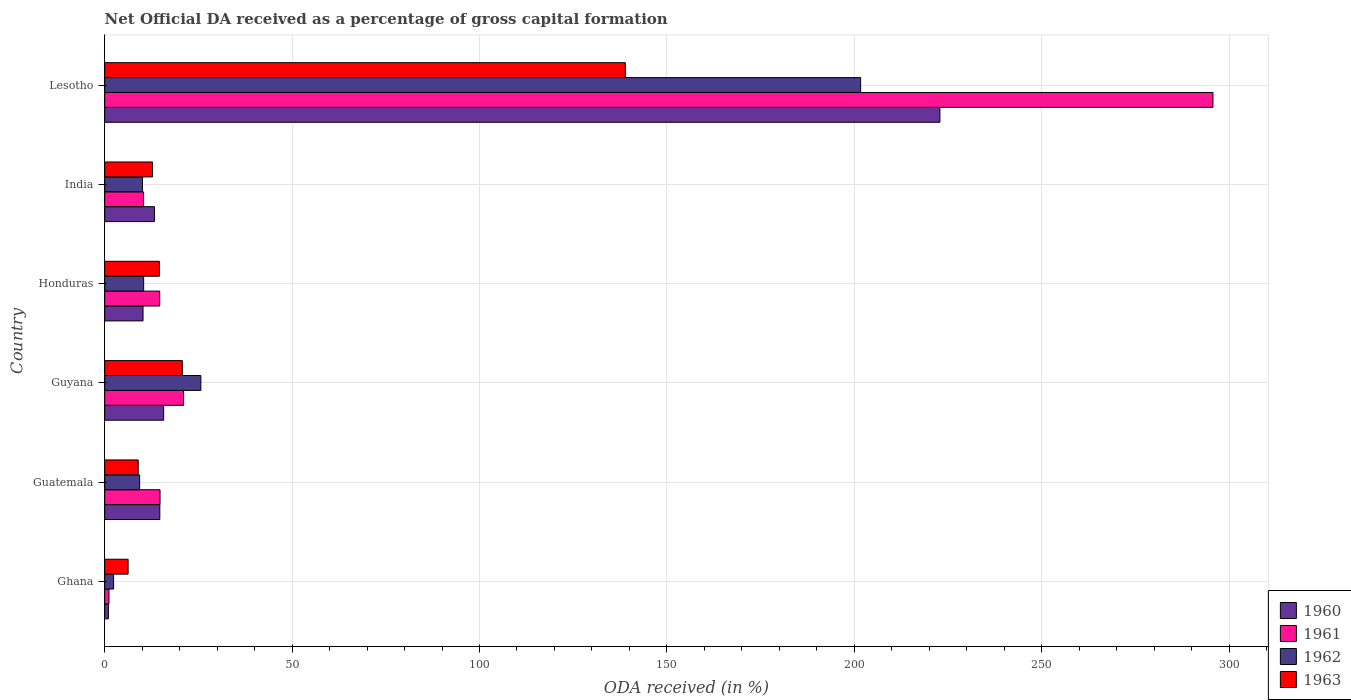How many bars are there on the 1st tick from the top?
Make the answer very short. 4. What is the label of the 5th group of bars from the top?
Ensure brevity in your answer.  Guatemala. In how many cases, is the number of bars for a given country not equal to the number of legend labels?
Offer a terse response. 0. What is the net ODA received in 1961 in Lesotho?
Make the answer very short. 295.71. Across all countries, what is the maximum net ODA received in 1962?
Give a very brief answer. 201.7. Across all countries, what is the minimum net ODA received in 1960?
Provide a short and direct response. 0.99. In which country was the net ODA received in 1960 maximum?
Ensure brevity in your answer.  Lesotho. In which country was the net ODA received in 1961 minimum?
Your answer should be very brief. Ghana. What is the total net ODA received in 1961 in the graph?
Give a very brief answer. 357.71. What is the difference between the net ODA received in 1963 in Guatemala and that in Guyana?
Your answer should be compact. -11.78. What is the difference between the net ODA received in 1960 in India and the net ODA received in 1963 in Guatemala?
Your answer should be compact. 4.34. What is the average net ODA received in 1962 per country?
Your answer should be very brief. 43.25. What is the difference between the net ODA received in 1963 and net ODA received in 1960 in Guyana?
Offer a very short reply. 4.98. In how many countries, is the net ODA received in 1963 greater than 120 %?
Your response must be concise. 1. What is the ratio of the net ODA received in 1962 in Ghana to that in Guatemala?
Provide a succinct answer. 0.25. Is the difference between the net ODA received in 1963 in Ghana and Lesotho greater than the difference between the net ODA received in 1960 in Ghana and Lesotho?
Offer a terse response. Yes. What is the difference between the highest and the second highest net ODA received in 1963?
Offer a terse response. 118.2. What is the difference between the highest and the lowest net ODA received in 1961?
Your answer should be compact. 294.58. Is it the case that in every country, the sum of the net ODA received in 1963 and net ODA received in 1961 is greater than the sum of net ODA received in 1960 and net ODA received in 1962?
Give a very brief answer. No. Is it the case that in every country, the sum of the net ODA received in 1963 and net ODA received in 1962 is greater than the net ODA received in 1961?
Give a very brief answer. Yes. How many countries are there in the graph?
Give a very brief answer. 6. Where does the legend appear in the graph?
Give a very brief answer. Bottom right. What is the title of the graph?
Your response must be concise. Net Official DA received as a percentage of gross capital formation. Does "2004" appear as one of the legend labels in the graph?
Your answer should be compact. No. What is the label or title of the X-axis?
Provide a short and direct response. ODA received (in %). What is the label or title of the Y-axis?
Provide a succinct answer. Country. What is the ODA received (in %) of 1960 in Ghana?
Your answer should be very brief. 0.99. What is the ODA received (in %) of 1961 in Ghana?
Provide a succinct answer. 1.13. What is the ODA received (in %) of 1962 in Ghana?
Offer a very short reply. 2.37. What is the ODA received (in %) of 1963 in Ghana?
Offer a terse response. 6.24. What is the ODA received (in %) in 1960 in Guatemala?
Provide a short and direct response. 14.71. What is the ODA received (in %) in 1961 in Guatemala?
Offer a terse response. 14.76. What is the ODA received (in %) in 1962 in Guatemala?
Keep it short and to the point. 9.31. What is the ODA received (in %) in 1963 in Guatemala?
Your answer should be very brief. 8.93. What is the ODA received (in %) of 1960 in Guyana?
Your answer should be very brief. 15.73. What is the ODA received (in %) of 1961 in Guyana?
Provide a succinct answer. 21.05. What is the ODA received (in %) in 1962 in Guyana?
Ensure brevity in your answer.  25.65. What is the ODA received (in %) in 1963 in Guyana?
Offer a terse response. 20.71. What is the ODA received (in %) in 1960 in Honduras?
Provide a short and direct response. 10.23. What is the ODA received (in %) of 1961 in Honduras?
Your answer should be very brief. 14.68. What is the ODA received (in %) in 1962 in Honduras?
Your answer should be compact. 10.39. What is the ODA received (in %) of 1963 in Honduras?
Your response must be concise. 14.59. What is the ODA received (in %) of 1960 in India?
Offer a very short reply. 13.27. What is the ODA received (in %) in 1961 in India?
Your answer should be compact. 10.37. What is the ODA received (in %) of 1962 in India?
Keep it short and to the point. 10.08. What is the ODA received (in %) in 1963 in India?
Your answer should be very brief. 12.76. What is the ODA received (in %) in 1960 in Lesotho?
Give a very brief answer. 222.86. What is the ODA received (in %) of 1961 in Lesotho?
Make the answer very short. 295.71. What is the ODA received (in %) of 1962 in Lesotho?
Make the answer very short. 201.7. What is the ODA received (in %) in 1963 in Lesotho?
Make the answer very short. 138.92. Across all countries, what is the maximum ODA received (in %) in 1960?
Give a very brief answer. 222.86. Across all countries, what is the maximum ODA received (in %) in 1961?
Keep it short and to the point. 295.71. Across all countries, what is the maximum ODA received (in %) in 1962?
Provide a short and direct response. 201.7. Across all countries, what is the maximum ODA received (in %) in 1963?
Your answer should be compact. 138.92. Across all countries, what is the minimum ODA received (in %) of 1960?
Offer a very short reply. 0.99. Across all countries, what is the minimum ODA received (in %) in 1961?
Provide a succinct answer. 1.13. Across all countries, what is the minimum ODA received (in %) in 1962?
Ensure brevity in your answer.  2.37. Across all countries, what is the minimum ODA received (in %) in 1963?
Offer a terse response. 6.24. What is the total ODA received (in %) in 1960 in the graph?
Offer a very short reply. 277.78. What is the total ODA received (in %) in 1961 in the graph?
Offer a terse response. 357.71. What is the total ODA received (in %) in 1962 in the graph?
Give a very brief answer. 259.51. What is the total ODA received (in %) of 1963 in the graph?
Provide a succinct answer. 202.15. What is the difference between the ODA received (in %) in 1960 in Ghana and that in Guatemala?
Give a very brief answer. -13.72. What is the difference between the ODA received (in %) in 1961 in Ghana and that in Guatemala?
Your response must be concise. -13.63. What is the difference between the ODA received (in %) in 1962 in Ghana and that in Guatemala?
Provide a short and direct response. -6.94. What is the difference between the ODA received (in %) of 1963 in Ghana and that in Guatemala?
Keep it short and to the point. -2.69. What is the difference between the ODA received (in %) of 1960 in Ghana and that in Guyana?
Ensure brevity in your answer.  -14.74. What is the difference between the ODA received (in %) in 1961 in Ghana and that in Guyana?
Offer a terse response. -19.91. What is the difference between the ODA received (in %) of 1962 in Ghana and that in Guyana?
Ensure brevity in your answer.  -23.28. What is the difference between the ODA received (in %) of 1963 in Ghana and that in Guyana?
Give a very brief answer. -14.47. What is the difference between the ODA received (in %) of 1960 in Ghana and that in Honduras?
Your answer should be very brief. -9.23. What is the difference between the ODA received (in %) of 1961 in Ghana and that in Honduras?
Provide a short and direct response. -13.54. What is the difference between the ODA received (in %) of 1962 in Ghana and that in Honduras?
Provide a succinct answer. -8.02. What is the difference between the ODA received (in %) of 1963 in Ghana and that in Honduras?
Offer a very short reply. -8.35. What is the difference between the ODA received (in %) of 1960 in Ghana and that in India?
Offer a terse response. -12.28. What is the difference between the ODA received (in %) of 1961 in Ghana and that in India?
Offer a terse response. -9.24. What is the difference between the ODA received (in %) in 1962 in Ghana and that in India?
Your answer should be very brief. -7.71. What is the difference between the ODA received (in %) of 1963 in Ghana and that in India?
Offer a very short reply. -6.51. What is the difference between the ODA received (in %) of 1960 in Ghana and that in Lesotho?
Offer a terse response. -221.87. What is the difference between the ODA received (in %) in 1961 in Ghana and that in Lesotho?
Provide a short and direct response. -294.58. What is the difference between the ODA received (in %) of 1962 in Ghana and that in Lesotho?
Give a very brief answer. -199.33. What is the difference between the ODA received (in %) of 1963 in Ghana and that in Lesotho?
Your answer should be compact. -132.67. What is the difference between the ODA received (in %) in 1960 in Guatemala and that in Guyana?
Provide a short and direct response. -1.02. What is the difference between the ODA received (in %) in 1961 in Guatemala and that in Guyana?
Give a very brief answer. -6.29. What is the difference between the ODA received (in %) of 1962 in Guatemala and that in Guyana?
Offer a very short reply. -16.34. What is the difference between the ODA received (in %) of 1963 in Guatemala and that in Guyana?
Ensure brevity in your answer.  -11.78. What is the difference between the ODA received (in %) in 1960 in Guatemala and that in Honduras?
Give a very brief answer. 4.48. What is the difference between the ODA received (in %) of 1961 in Guatemala and that in Honduras?
Make the answer very short. 0.08. What is the difference between the ODA received (in %) of 1962 in Guatemala and that in Honduras?
Give a very brief answer. -1.08. What is the difference between the ODA received (in %) of 1963 in Guatemala and that in Honduras?
Provide a short and direct response. -5.66. What is the difference between the ODA received (in %) of 1960 in Guatemala and that in India?
Offer a very short reply. 1.44. What is the difference between the ODA received (in %) in 1961 in Guatemala and that in India?
Provide a succinct answer. 4.39. What is the difference between the ODA received (in %) of 1962 in Guatemala and that in India?
Your response must be concise. -0.77. What is the difference between the ODA received (in %) of 1963 in Guatemala and that in India?
Offer a very short reply. -3.82. What is the difference between the ODA received (in %) of 1960 in Guatemala and that in Lesotho?
Ensure brevity in your answer.  -208.15. What is the difference between the ODA received (in %) in 1961 in Guatemala and that in Lesotho?
Provide a succinct answer. -280.95. What is the difference between the ODA received (in %) in 1962 in Guatemala and that in Lesotho?
Ensure brevity in your answer.  -192.39. What is the difference between the ODA received (in %) in 1963 in Guatemala and that in Lesotho?
Your answer should be very brief. -129.98. What is the difference between the ODA received (in %) of 1960 in Guyana and that in Honduras?
Give a very brief answer. 5.5. What is the difference between the ODA received (in %) in 1961 in Guyana and that in Honduras?
Give a very brief answer. 6.37. What is the difference between the ODA received (in %) in 1962 in Guyana and that in Honduras?
Make the answer very short. 15.26. What is the difference between the ODA received (in %) of 1963 in Guyana and that in Honduras?
Your answer should be very brief. 6.12. What is the difference between the ODA received (in %) of 1960 in Guyana and that in India?
Keep it short and to the point. 2.46. What is the difference between the ODA received (in %) in 1961 in Guyana and that in India?
Provide a short and direct response. 10.67. What is the difference between the ODA received (in %) of 1962 in Guyana and that in India?
Ensure brevity in your answer.  15.57. What is the difference between the ODA received (in %) in 1963 in Guyana and that in India?
Keep it short and to the point. 7.96. What is the difference between the ODA received (in %) in 1960 in Guyana and that in Lesotho?
Offer a very short reply. -207.13. What is the difference between the ODA received (in %) in 1961 in Guyana and that in Lesotho?
Ensure brevity in your answer.  -274.67. What is the difference between the ODA received (in %) in 1962 in Guyana and that in Lesotho?
Make the answer very short. -176.05. What is the difference between the ODA received (in %) in 1963 in Guyana and that in Lesotho?
Give a very brief answer. -118.2. What is the difference between the ODA received (in %) of 1960 in Honduras and that in India?
Provide a short and direct response. -3.05. What is the difference between the ODA received (in %) in 1961 in Honduras and that in India?
Give a very brief answer. 4.3. What is the difference between the ODA received (in %) in 1962 in Honduras and that in India?
Your response must be concise. 0.31. What is the difference between the ODA received (in %) in 1963 in Honduras and that in India?
Keep it short and to the point. 1.84. What is the difference between the ODA received (in %) of 1960 in Honduras and that in Lesotho?
Provide a short and direct response. -212.63. What is the difference between the ODA received (in %) in 1961 in Honduras and that in Lesotho?
Provide a succinct answer. -281.04. What is the difference between the ODA received (in %) in 1962 in Honduras and that in Lesotho?
Give a very brief answer. -191.31. What is the difference between the ODA received (in %) of 1963 in Honduras and that in Lesotho?
Offer a very short reply. -124.33. What is the difference between the ODA received (in %) in 1960 in India and that in Lesotho?
Your answer should be very brief. -209.59. What is the difference between the ODA received (in %) in 1961 in India and that in Lesotho?
Your response must be concise. -285.34. What is the difference between the ODA received (in %) of 1962 in India and that in Lesotho?
Ensure brevity in your answer.  -191.62. What is the difference between the ODA received (in %) of 1963 in India and that in Lesotho?
Provide a succinct answer. -126.16. What is the difference between the ODA received (in %) in 1960 in Ghana and the ODA received (in %) in 1961 in Guatemala?
Your answer should be compact. -13.77. What is the difference between the ODA received (in %) of 1960 in Ghana and the ODA received (in %) of 1962 in Guatemala?
Provide a succinct answer. -8.32. What is the difference between the ODA received (in %) in 1960 in Ghana and the ODA received (in %) in 1963 in Guatemala?
Your answer should be compact. -7.94. What is the difference between the ODA received (in %) of 1961 in Ghana and the ODA received (in %) of 1962 in Guatemala?
Ensure brevity in your answer.  -8.18. What is the difference between the ODA received (in %) in 1961 in Ghana and the ODA received (in %) in 1963 in Guatemala?
Offer a very short reply. -7.8. What is the difference between the ODA received (in %) in 1962 in Ghana and the ODA received (in %) in 1963 in Guatemala?
Your response must be concise. -6.56. What is the difference between the ODA received (in %) of 1960 in Ghana and the ODA received (in %) of 1961 in Guyana?
Your response must be concise. -20.06. What is the difference between the ODA received (in %) in 1960 in Ghana and the ODA received (in %) in 1962 in Guyana?
Give a very brief answer. -24.66. What is the difference between the ODA received (in %) in 1960 in Ghana and the ODA received (in %) in 1963 in Guyana?
Keep it short and to the point. -19.72. What is the difference between the ODA received (in %) in 1961 in Ghana and the ODA received (in %) in 1962 in Guyana?
Keep it short and to the point. -24.52. What is the difference between the ODA received (in %) of 1961 in Ghana and the ODA received (in %) of 1963 in Guyana?
Keep it short and to the point. -19.58. What is the difference between the ODA received (in %) of 1962 in Ghana and the ODA received (in %) of 1963 in Guyana?
Offer a very short reply. -18.34. What is the difference between the ODA received (in %) in 1960 in Ghana and the ODA received (in %) in 1961 in Honduras?
Give a very brief answer. -13.69. What is the difference between the ODA received (in %) of 1960 in Ghana and the ODA received (in %) of 1962 in Honduras?
Your answer should be compact. -9.4. What is the difference between the ODA received (in %) in 1960 in Ghana and the ODA received (in %) in 1963 in Honduras?
Keep it short and to the point. -13.6. What is the difference between the ODA received (in %) in 1961 in Ghana and the ODA received (in %) in 1962 in Honduras?
Provide a succinct answer. -9.26. What is the difference between the ODA received (in %) in 1961 in Ghana and the ODA received (in %) in 1963 in Honduras?
Offer a terse response. -13.46. What is the difference between the ODA received (in %) of 1962 in Ghana and the ODA received (in %) of 1963 in Honduras?
Make the answer very short. -12.22. What is the difference between the ODA received (in %) in 1960 in Ghana and the ODA received (in %) in 1961 in India?
Offer a very short reply. -9.38. What is the difference between the ODA received (in %) of 1960 in Ghana and the ODA received (in %) of 1962 in India?
Provide a succinct answer. -9.09. What is the difference between the ODA received (in %) of 1960 in Ghana and the ODA received (in %) of 1963 in India?
Provide a short and direct response. -11.77. What is the difference between the ODA received (in %) in 1961 in Ghana and the ODA received (in %) in 1962 in India?
Make the answer very short. -8.95. What is the difference between the ODA received (in %) of 1961 in Ghana and the ODA received (in %) of 1963 in India?
Your answer should be compact. -11.62. What is the difference between the ODA received (in %) of 1962 in Ghana and the ODA received (in %) of 1963 in India?
Ensure brevity in your answer.  -10.39. What is the difference between the ODA received (in %) of 1960 in Ghana and the ODA received (in %) of 1961 in Lesotho?
Provide a short and direct response. -294.72. What is the difference between the ODA received (in %) in 1960 in Ghana and the ODA received (in %) in 1962 in Lesotho?
Provide a short and direct response. -200.71. What is the difference between the ODA received (in %) in 1960 in Ghana and the ODA received (in %) in 1963 in Lesotho?
Ensure brevity in your answer.  -137.93. What is the difference between the ODA received (in %) in 1961 in Ghana and the ODA received (in %) in 1962 in Lesotho?
Give a very brief answer. -200.57. What is the difference between the ODA received (in %) of 1961 in Ghana and the ODA received (in %) of 1963 in Lesotho?
Provide a short and direct response. -137.78. What is the difference between the ODA received (in %) of 1962 in Ghana and the ODA received (in %) of 1963 in Lesotho?
Keep it short and to the point. -136.55. What is the difference between the ODA received (in %) of 1960 in Guatemala and the ODA received (in %) of 1961 in Guyana?
Provide a succinct answer. -6.34. What is the difference between the ODA received (in %) in 1960 in Guatemala and the ODA received (in %) in 1962 in Guyana?
Provide a short and direct response. -10.95. What is the difference between the ODA received (in %) in 1960 in Guatemala and the ODA received (in %) in 1963 in Guyana?
Make the answer very short. -6.01. What is the difference between the ODA received (in %) of 1961 in Guatemala and the ODA received (in %) of 1962 in Guyana?
Provide a short and direct response. -10.89. What is the difference between the ODA received (in %) in 1961 in Guatemala and the ODA received (in %) in 1963 in Guyana?
Ensure brevity in your answer.  -5.95. What is the difference between the ODA received (in %) of 1962 in Guatemala and the ODA received (in %) of 1963 in Guyana?
Offer a terse response. -11.4. What is the difference between the ODA received (in %) in 1960 in Guatemala and the ODA received (in %) in 1961 in Honduras?
Your answer should be compact. 0.03. What is the difference between the ODA received (in %) in 1960 in Guatemala and the ODA received (in %) in 1962 in Honduras?
Ensure brevity in your answer.  4.32. What is the difference between the ODA received (in %) in 1960 in Guatemala and the ODA received (in %) in 1963 in Honduras?
Your answer should be compact. 0.12. What is the difference between the ODA received (in %) of 1961 in Guatemala and the ODA received (in %) of 1962 in Honduras?
Provide a succinct answer. 4.37. What is the difference between the ODA received (in %) of 1961 in Guatemala and the ODA received (in %) of 1963 in Honduras?
Make the answer very short. 0.17. What is the difference between the ODA received (in %) of 1962 in Guatemala and the ODA received (in %) of 1963 in Honduras?
Offer a very short reply. -5.28. What is the difference between the ODA received (in %) of 1960 in Guatemala and the ODA received (in %) of 1961 in India?
Ensure brevity in your answer.  4.33. What is the difference between the ODA received (in %) in 1960 in Guatemala and the ODA received (in %) in 1962 in India?
Offer a terse response. 4.63. What is the difference between the ODA received (in %) in 1960 in Guatemala and the ODA received (in %) in 1963 in India?
Offer a terse response. 1.95. What is the difference between the ODA received (in %) of 1961 in Guatemala and the ODA received (in %) of 1962 in India?
Your response must be concise. 4.68. What is the difference between the ODA received (in %) in 1961 in Guatemala and the ODA received (in %) in 1963 in India?
Your answer should be very brief. 2. What is the difference between the ODA received (in %) in 1962 in Guatemala and the ODA received (in %) in 1963 in India?
Make the answer very short. -3.44. What is the difference between the ODA received (in %) in 1960 in Guatemala and the ODA received (in %) in 1961 in Lesotho?
Ensure brevity in your answer.  -281.01. What is the difference between the ODA received (in %) in 1960 in Guatemala and the ODA received (in %) in 1962 in Lesotho?
Give a very brief answer. -186.99. What is the difference between the ODA received (in %) in 1960 in Guatemala and the ODA received (in %) in 1963 in Lesotho?
Make the answer very short. -124.21. What is the difference between the ODA received (in %) in 1961 in Guatemala and the ODA received (in %) in 1962 in Lesotho?
Offer a very short reply. -186.94. What is the difference between the ODA received (in %) in 1961 in Guatemala and the ODA received (in %) in 1963 in Lesotho?
Offer a terse response. -124.16. What is the difference between the ODA received (in %) of 1962 in Guatemala and the ODA received (in %) of 1963 in Lesotho?
Your answer should be very brief. -129.6. What is the difference between the ODA received (in %) of 1960 in Guyana and the ODA received (in %) of 1961 in Honduras?
Provide a succinct answer. 1.05. What is the difference between the ODA received (in %) in 1960 in Guyana and the ODA received (in %) in 1962 in Honduras?
Give a very brief answer. 5.34. What is the difference between the ODA received (in %) in 1960 in Guyana and the ODA received (in %) in 1963 in Honduras?
Your answer should be very brief. 1.14. What is the difference between the ODA received (in %) in 1961 in Guyana and the ODA received (in %) in 1962 in Honduras?
Your response must be concise. 10.66. What is the difference between the ODA received (in %) of 1961 in Guyana and the ODA received (in %) of 1963 in Honduras?
Provide a succinct answer. 6.46. What is the difference between the ODA received (in %) of 1962 in Guyana and the ODA received (in %) of 1963 in Honduras?
Keep it short and to the point. 11.06. What is the difference between the ODA received (in %) in 1960 in Guyana and the ODA received (in %) in 1961 in India?
Ensure brevity in your answer.  5.36. What is the difference between the ODA received (in %) of 1960 in Guyana and the ODA received (in %) of 1962 in India?
Provide a succinct answer. 5.65. What is the difference between the ODA received (in %) of 1960 in Guyana and the ODA received (in %) of 1963 in India?
Your answer should be compact. 2.97. What is the difference between the ODA received (in %) in 1961 in Guyana and the ODA received (in %) in 1962 in India?
Offer a terse response. 10.97. What is the difference between the ODA received (in %) of 1961 in Guyana and the ODA received (in %) of 1963 in India?
Make the answer very short. 8.29. What is the difference between the ODA received (in %) in 1962 in Guyana and the ODA received (in %) in 1963 in India?
Your answer should be very brief. 12.9. What is the difference between the ODA received (in %) of 1960 in Guyana and the ODA received (in %) of 1961 in Lesotho?
Give a very brief answer. -279.98. What is the difference between the ODA received (in %) in 1960 in Guyana and the ODA received (in %) in 1962 in Lesotho?
Your answer should be very brief. -185.97. What is the difference between the ODA received (in %) of 1960 in Guyana and the ODA received (in %) of 1963 in Lesotho?
Offer a terse response. -123.19. What is the difference between the ODA received (in %) of 1961 in Guyana and the ODA received (in %) of 1962 in Lesotho?
Offer a terse response. -180.65. What is the difference between the ODA received (in %) in 1961 in Guyana and the ODA received (in %) in 1963 in Lesotho?
Give a very brief answer. -117.87. What is the difference between the ODA received (in %) in 1962 in Guyana and the ODA received (in %) in 1963 in Lesotho?
Provide a short and direct response. -113.26. What is the difference between the ODA received (in %) of 1960 in Honduras and the ODA received (in %) of 1961 in India?
Ensure brevity in your answer.  -0.15. What is the difference between the ODA received (in %) in 1960 in Honduras and the ODA received (in %) in 1962 in India?
Offer a terse response. 0.14. What is the difference between the ODA received (in %) in 1960 in Honduras and the ODA received (in %) in 1963 in India?
Give a very brief answer. -2.53. What is the difference between the ODA received (in %) in 1961 in Honduras and the ODA received (in %) in 1962 in India?
Offer a very short reply. 4.6. What is the difference between the ODA received (in %) in 1961 in Honduras and the ODA received (in %) in 1963 in India?
Keep it short and to the point. 1.92. What is the difference between the ODA received (in %) in 1962 in Honduras and the ODA received (in %) in 1963 in India?
Offer a terse response. -2.37. What is the difference between the ODA received (in %) of 1960 in Honduras and the ODA received (in %) of 1961 in Lesotho?
Provide a short and direct response. -285.49. What is the difference between the ODA received (in %) in 1960 in Honduras and the ODA received (in %) in 1962 in Lesotho?
Your answer should be compact. -191.48. What is the difference between the ODA received (in %) in 1960 in Honduras and the ODA received (in %) in 1963 in Lesotho?
Make the answer very short. -128.69. What is the difference between the ODA received (in %) of 1961 in Honduras and the ODA received (in %) of 1962 in Lesotho?
Provide a short and direct response. -187.02. What is the difference between the ODA received (in %) of 1961 in Honduras and the ODA received (in %) of 1963 in Lesotho?
Keep it short and to the point. -124.24. What is the difference between the ODA received (in %) in 1962 in Honduras and the ODA received (in %) in 1963 in Lesotho?
Give a very brief answer. -128.53. What is the difference between the ODA received (in %) in 1960 in India and the ODA received (in %) in 1961 in Lesotho?
Your response must be concise. -282.44. What is the difference between the ODA received (in %) of 1960 in India and the ODA received (in %) of 1962 in Lesotho?
Provide a succinct answer. -188.43. What is the difference between the ODA received (in %) of 1960 in India and the ODA received (in %) of 1963 in Lesotho?
Provide a short and direct response. -125.65. What is the difference between the ODA received (in %) in 1961 in India and the ODA received (in %) in 1962 in Lesotho?
Ensure brevity in your answer.  -191.33. What is the difference between the ODA received (in %) of 1961 in India and the ODA received (in %) of 1963 in Lesotho?
Your answer should be compact. -128.54. What is the difference between the ODA received (in %) of 1962 in India and the ODA received (in %) of 1963 in Lesotho?
Make the answer very short. -128.84. What is the average ODA received (in %) of 1960 per country?
Give a very brief answer. 46.3. What is the average ODA received (in %) in 1961 per country?
Keep it short and to the point. 59.62. What is the average ODA received (in %) in 1962 per country?
Your answer should be compact. 43.25. What is the average ODA received (in %) of 1963 per country?
Offer a very short reply. 33.69. What is the difference between the ODA received (in %) of 1960 and ODA received (in %) of 1961 in Ghana?
Provide a succinct answer. -0.14. What is the difference between the ODA received (in %) in 1960 and ODA received (in %) in 1962 in Ghana?
Offer a terse response. -1.38. What is the difference between the ODA received (in %) of 1960 and ODA received (in %) of 1963 in Ghana?
Give a very brief answer. -5.25. What is the difference between the ODA received (in %) of 1961 and ODA received (in %) of 1962 in Ghana?
Keep it short and to the point. -1.24. What is the difference between the ODA received (in %) of 1961 and ODA received (in %) of 1963 in Ghana?
Provide a succinct answer. -5.11. What is the difference between the ODA received (in %) of 1962 and ODA received (in %) of 1963 in Ghana?
Give a very brief answer. -3.87. What is the difference between the ODA received (in %) of 1960 and ODA received (in %) of 1961 in Guatemala?
Keep it short and to the point. -0.05. What is the difference between the ODA received (in %) of 1960 and ODA received (in %) of 1962 in Guatemala?
Offer a very short reply. 5.39. What is the difference between the ODA received (in %) in 1960 and ODA received (in %) in 1963 in Guatemala?
Give a very brief answer. 5.77. What is the difference between the ODA received (in %) in 1961 and ODA received (in %) in 1962 in Guatemala?
Make the answer very short. 5.45. What is the difference between the ODA received (in %) in 1961 and ODA received (in %) in 1963 in Guatemala?
Your answer should be very brief. 5.83. What is the difference between the ODA received (in %) of 1962 and ODA received (in %) of 1963 in Guatemala?
Your answer should be very brief. 0.38. What is the difference between the ODA received (in %) in 1960 and ODA received (in %) in 1961 in Guyana?
Provide a short and direct response. -5.32. What is the difference between the ODA received (in %) of 1960 and ODA received (in %) of 1962 in Guyana?
Provide a short and direct response. -9.92. What is the difference between the ODA received (in %) of 1960 and ODA received (in %) of 1963 in Guyana?
Ensure brevity in your answer.  -4.98. What is the difference between the ODA received (in %) in 1961 and ODA received (in %) in 1962 in Guyana?
Your response must be concise. -4.61. What is the difference between the ODA received (in %) in 1961 and ODA received (in %) in 1963 in Guyana?
Provide a short and direct response. 0.33. What is the difference between the ODA received (in %) of 1962 and ODA received (in %) of 1963 in Guyana?
Your response must be concise. 4.94. What is the difference between the ODA received (in %) of 1960 and ODA received (in %) of 1961 in Honduras?
Ensure brevity in your answer.  -4.45. What is the difference between the ODA received (in %) in 1960 and ODA received (in %) in 1962 in Honduras?
Offer a terse response. -0.16. What is the difference between the ODA received (in %) in 1960 and ODA received (in %) in 1963 in Honduras?
Your answer should be compact. -4.37. What is the difference between the ODA received (in %) of 1961 and ODA received (in %) of 1962 in Honduras?
Your response must be concise. 4.29. What is the difference between the ODA received (in %) of 1961 and ODA received (in %) of 1963 in Honduras?
Give a very brief answer. 0.09. What is the difference between the ODA received (in %) of 1962 and ODA received (in %) of 1963 in Honduras?
Your answer should be very brief. -4.2. What is the difference between the ODA received (in %) of 1960 and ODA received (in %) of 1961 in India?
Offer a terse response. 2.9. What is the difference between the ODA received (in %) in 1960 and ODA received (in %) in 1962 in India?
Give a very brief answer. 3.19. What is the difference between the ODA received (in %) of 1960 and ODA received (in %) of 1963 in India?
Give a very brief answer. 0.52. What is the difference between the ODA received (in %) of 1961 and ODA received (in %) of 1962 in India?
Provide a short and direct response. 0.29. What is the difference between the ODA received (in %) of 1961 and ODA received (in %) of 1963 in India?
Your answer should be compact. -2.38. What is the difference between the ODA received (in %) of 1962 and ODA received (in %) of 1963 in India?
Offer a very short reply. -2.68. What is the difference between the ODA received (in %) in 1960 and ODA received (in %) in 1961 in Lesotho?
Offer a terse response. -72.86. What is the difference between the ODA received (in %) of 1960 and ODA received (in %) of 1962 in Lesotho?
Provide a short and direct response. 21.16. What is the difference between the ODA received (in %) in 1960 and ODA received (in %) in 1963 in Lesotho?
Ensure brevity in your answer.  83.94. What is the difference between the ODA received (in %) of 1961 and ODA received (in %) of 1962 in Lesotho?
Make the answer very short. 94.01. What is the difference between the ODA received (in %) of 1961 and ODA received (in %) of 1963 in Lesotho?
Offer a terse response. 156.8. What is the difference between the ODA received (in %) in 1962 and ODA received (in %) in 1963 in Lesotho?
Provide a short and direct response. 62.78. What is the ratio of the ODA received (in %) of 1960 in Ghana to that in Guatemala?
Make the answer very short. 0.07. What is the ratio of the ODA received (in %) of 1961 in Ghana to that in Guatemala?
Keep it short and to the point. 0.08. What is the ratio of the ODA received (in %) of 1962 in Ghana to that in Guatemala?
Ensure brevity in your answer.  0.25. What is the ratio of the ODA received (in %) of 1963 in Ghana to that in Guatemala?
Make the answer very short. 0.7. What is the ratio of the ODA received (in %) in 1960 in Ghana to that in Guyana?
Keep it short and to the point. 0.06. What is the ratio of the ODA received (in %) of 1961 in Ghana to that in Guyana?
Your response must be concise. 0.05. What is the ratio of the ODA received (in %) of 1962 in Ghana to that in Guyana?
Your response must be concise. 0.09. What is the ratio of the ODA received (in %) of 1963 in Ghana to that in Guyana?
Keep it short and to the point. 0.3. What is the ratio of the ODA received (in %) of 1960 in Ghana to that in Honduras?
Ensure brevity in your answer.  0.1. What is the ratio of the ODA received (in %) of 1961 in Ghana to that in Honduras?
Your answer should be compact. 0.08. What is the ratio of the ODA received (in %) in 1962 in Ghana to that in Honduras?
Offer a terse response. 0.23. What is the ratio of the ODA received (in %) in 1963 in Ghana to that in Honduras?
Ensure brevity in your answer.  0.43. What is the ratio of the ODA received (in %) in 1960 in Ghana to that in India?
Give a very brief answer. 0.07. What is the ratio of the ODA received (in %) of 1961 in Ghana to that in India?
Provide a short and direct response. 0.11. What is the ratio of the ODA received (in %) of 1962 in Ghana to that in India?
Ensure brevity in your answer.  0.24. What is the ratio of the ODA received (in %) of 1963 in Ghana to that in India?
Provide a succinct answer. 0.49. What is the ratio of the ODA received (in %) of 1960 in Ghana to that in Lesotho?
Provide a succinct answer. 0. What is the ratio of the ODA received (in %) of 1961 in Ghana to that in Lesotho?
Make the answer very short. 0. What is the ratio of the ODA received (in %) of 1962 in Ghana to that in Lesotho?
Your answer should be very brief. 0.01. What is the ratio of the ODA received (in %) of 1963 in Ghana to that in Lesotho?
Offer a very short reply. 0.04. What is the ratio of the ODA received (in %) of 1960 in Guatemala to that in Guyana?
Keep it short and to the point. 0.94. What is the ratio of the ODA received (in %) of 1961 in Guatemala to that in Guyana?
Provide a short and direct response. 0.7. What is the ratio of the ODA received (in %) in 1962 in Guatemala to that in Guyana?
Provide a succinct answer. 0.36. What is the ratio of the ODA received (in %) of 1963 in Guatemala to that in Guyana?
Your answer should be compact. 0.43. What is the ratio of the ODA received (in %) in 1960 in Guatemala to that in Honduras?
Ensure brevity in your answer.  1.44. What is the ratio of the ODA received (in %) of 1962 in Guatemala to that in Honduras?
Give a very brief answer. 0.9. What is the ratio of the ODA received (in %) in 1963 in Guatemala to that in Honduras?
Offer a very short reply. 0.61. What is the ratio of the ODA received (in %) of 1960 in Guatemala to that in India?
Offer a very short reply. 1.11. What is the ratio of the ODA received (in %) of 1961 in Guatemala to that in India?
Keep it short and to the point. 1.42. What is the ratio of the ODA received (in %) in 1962 in Guatemala to that in India?
Make the answer very short. 0.92. What is the ratio of the ODA received (in %) in 1963 in Guatemala to that in India?
Give a very brief answer. 0.7. What is the ratio of the ODA received (in %) of 1960 in Guatemala to that in Lesotho?
Keep it short and to the point. 0.07. What is the ratio of the ODA received (in %) in 1961 in Guatemala to that in Lesotho?
Your answer should be very brief. 0.05. What is the ratio of the ODA received (in %) in 1962 in Guatemala to that in Lesotho?
Your answer should be compact. 0.05. What is the ratio of the ODA received (in %) in 1963 in Guatemala to that in Lesotho?
Your response must be concise. 0.06. What is the ratio of the ODA received (in %) in 1960 in Guyana to that in Honduras?
Your answer should be compact. 1.54. What is the ratio of the ODA received (in %) in 1961 in Guyana to that in Honduras?
Give a very brief answer. 1.43. What is the ratio of the ODA received (in %) of 1962 in Guyana to that in Honduras?
Your answer should be compact. 2.47. What is the ratio of the ODA received (in %) of 1963 in Guyana to that in Honduras?
Provide a short and direct response. 1.42. What is the ratio of the ODA received (in %) in 1960 in Guyana to that in India?
Offer a terse response. 1.19. What is the ratio of the ODA received (in %) in 1961 in Guyana to that in India?
Ensure brevity in your answer.  2.03. What is the ratio of the ODA received (in %) in 1962 in Guyana to that in India?
Offer a terse response. 2.54. What is the ratio of the ODA received (in %) in 1963 in Guyana to that in India?
Your response must be concise. 1.62. What is the ratio of the ODA received (in %) of 1960 in Guyana to that in Lesotho?
Provide a succinct answer. 0.07. What is the ratio of the ODA received (in %) of 1961 in Guyana to that in Lesotho?
Provide a short and direct response. 0.07. What is the ratio of the ODA received (in %) in 1962 in Guyana to that in Lesotho?
Offer a very short reply. 0.13. What is the ratio of the ODA received (in %) of 1963 in Guyana to that in Lesotho?
Provide a short and direct response. 0.15. What is the ratio of the ODA received (in %) of 1960 in Honduras to that in India?
Offer a terse response. 0.77. What is the ratio of the ODA received (in %) in 1961 in Honduras to that in India?
Your response must be concise. 1.41. What is the ratio of the ODA received (in %) in 1962 in Honduras to that in India?
Keep it short and to the point. 1.03. What is the ratio of the ODA received (in %) in 1963 in Honduras to that in India?
Offer a very short reply. 1.14. What is the ratio of the ODA received (in %) of 1960 in Honduras to that in Lesotho?
Provide a succinct answer. 0.05. What is the ratio of the ODA received (in %) in 1961 in Honduras to that in Lesotho?
Provide a short and direct response. 0.05. What is the ratio of the ODA received (in %) in 1962 in Honduras to that in Lesotho?
Give a very brief answer. 0.05. What is the ratio of the ODA received (in %) in 1963 in Honduras to that in Lesotho?
Offer a very short reply. 0.1. What is the ratio of the ODA received (in %) in 1960 in India to that in Lesotho?
Offer a terse response. 0.06. What is the ratio of the ODA received (in %) in 1961 in India to that in Lesotho?
Offer a very short reply. 0.04. What is the ratio of the ODA received (in %) in 1962 in India to that in Lesotho?
Make the answer very short. 0.05. What is the ratio of the ODA received (in %) of 1963 in India to that in Lesotho?
Your response must be concise. 0.09. What is the difference between the highest and the second highest ODA received (in %) of 1960?
Offer a very short reply. 207.13. What is the difference between the highest and the second highest ODA received (in %) in 1961?
Offer a very short reply. 274.67. What is the difference between the highest and the second highest ODA received (in %) in 1962?
Make the answer very short. 176.05. What is the difference between the highest and the second highest ODA received (in %) of 1963?
Offer a very short reply. 118.2. What is the difference between the highest and the lowest ODA received (in %) in 1960?
Make the answer very short. 221.87. What is the difference between the highest and the lowest ODA received (in %) of 1961?
Give a very brief answer. 294.58. What is the difference between the highest and the lowest ODA received (in %) in 1962?
Your answer should be compact. 199.33. What is the difference between the highest and the lowest ODA received (in %) of 1963?
Provide a succinct answer. 132.67. 